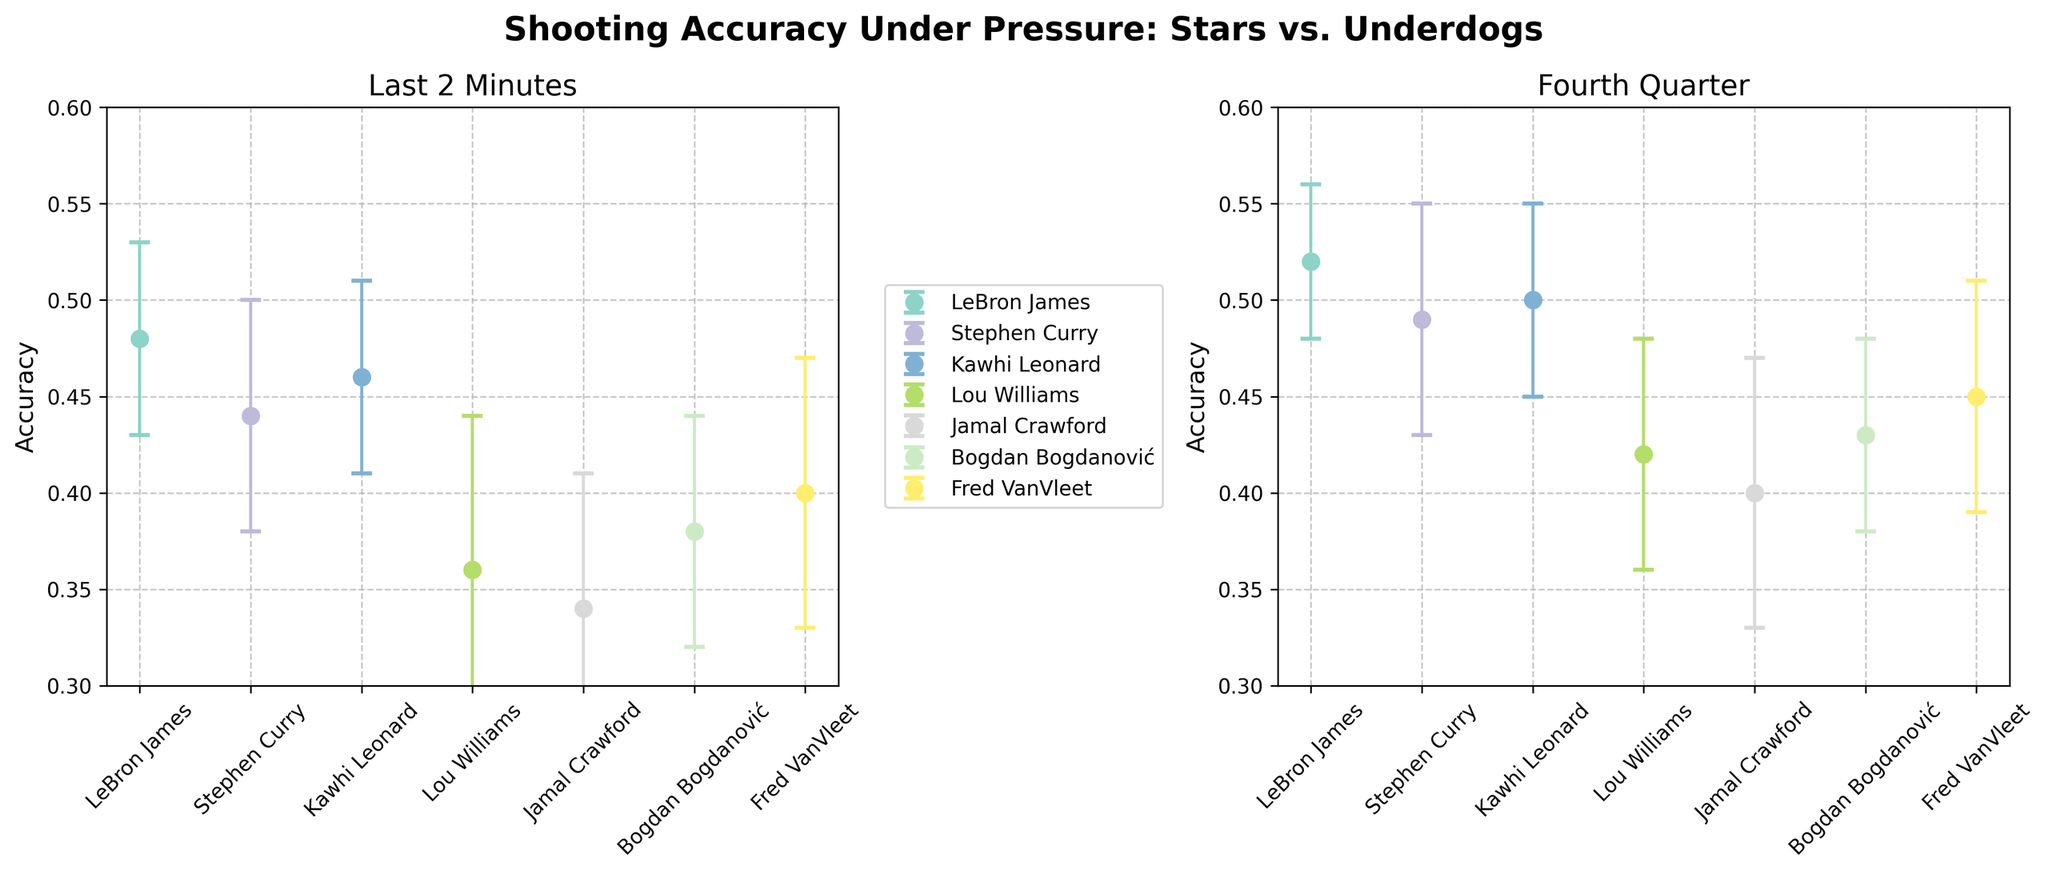What is the title of the figure? The title is located at the top of the figure in bold text.
Answer: Shooting Accuracy Under Pressure: Stars vs. Underdogs Which player has the highest shooting accuracy in the Fourth Quarter? Refer to the subplot titled "Fourth Quarter." Locate the player with the highest point on the y-axis.
Answer: LeBron James How many players are represented in the figure? Count the number of unique players displayed in the chart.
Answer: 6 What is Stephen Curry's shooting accuracy in the Last 2 Minutes, and what is his standard deviation? Find Stephen Curry's data point in the "Last 2 Minutes" subplot. Note the y-axis value for accuracy and error bar length for standard deviation.
Answer: 0.44, 0.06 Which lesser-known player has the best shooting accuracy in the Fourth Quarter? Consider lesser-known players (Lou Williams, Jamal Crawford, Bogdan Bogdanović, Fred VanVleet). Compare their accuracy in the "Fourth Quarter" subplot.
Answer: Fred VanVleet What is the difference in shooting accuracy between LeBron James and Jamal Crawford in the Last 2 Minutes? Subtract Jamal Crawford's accuracy from LeBron James's accuracy in the "Last 2 Minutes" subplot.
Answer: 0.14 Which player has the largest standard deviation for shooting accuracy in the Last 2 Minutes? Look at the error bars in the "Last 2 Minutes" subplot. Identify the player with the longest error bar.
Answer: Lou Williams Do any players have equal shooting accuracy in the Fourth Quarter? Check for players that have the same y-axis value in the "Fourth Quarter" subplot.
Answer: None Compare the shooting accuracies of Kawhi Leonard and Bogdan Bogdanović in the Fourth Quarter. Which one is higher? Locate both players in the "Fourth Quarter" subplot and compare their y-axis values.
Answer: Kawhi Leonard Is LeBron James' shooting accuracy higher in the Last 2 Minutes or the Fourth Quarter? Compare LeBron James’ accuracy values between the two subplots.
Answer: Fourth Quarter 